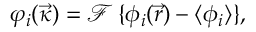<formula> <loc_0><loc_0><loc_500><loc_500>\varphi _ { i } ( \vec { \kappa } ) = \mathcal { F } \, \{ \phi _ { i } ( \vec { r } ) - \langle \phi _ { i } \rangle \} ,</formula> 